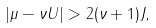<formula> <loc_0><loc_0><loc_500><loc_500>\left | \mu - \nu U \right | > 2 ( \nu + 1 ) J ,</formula> 